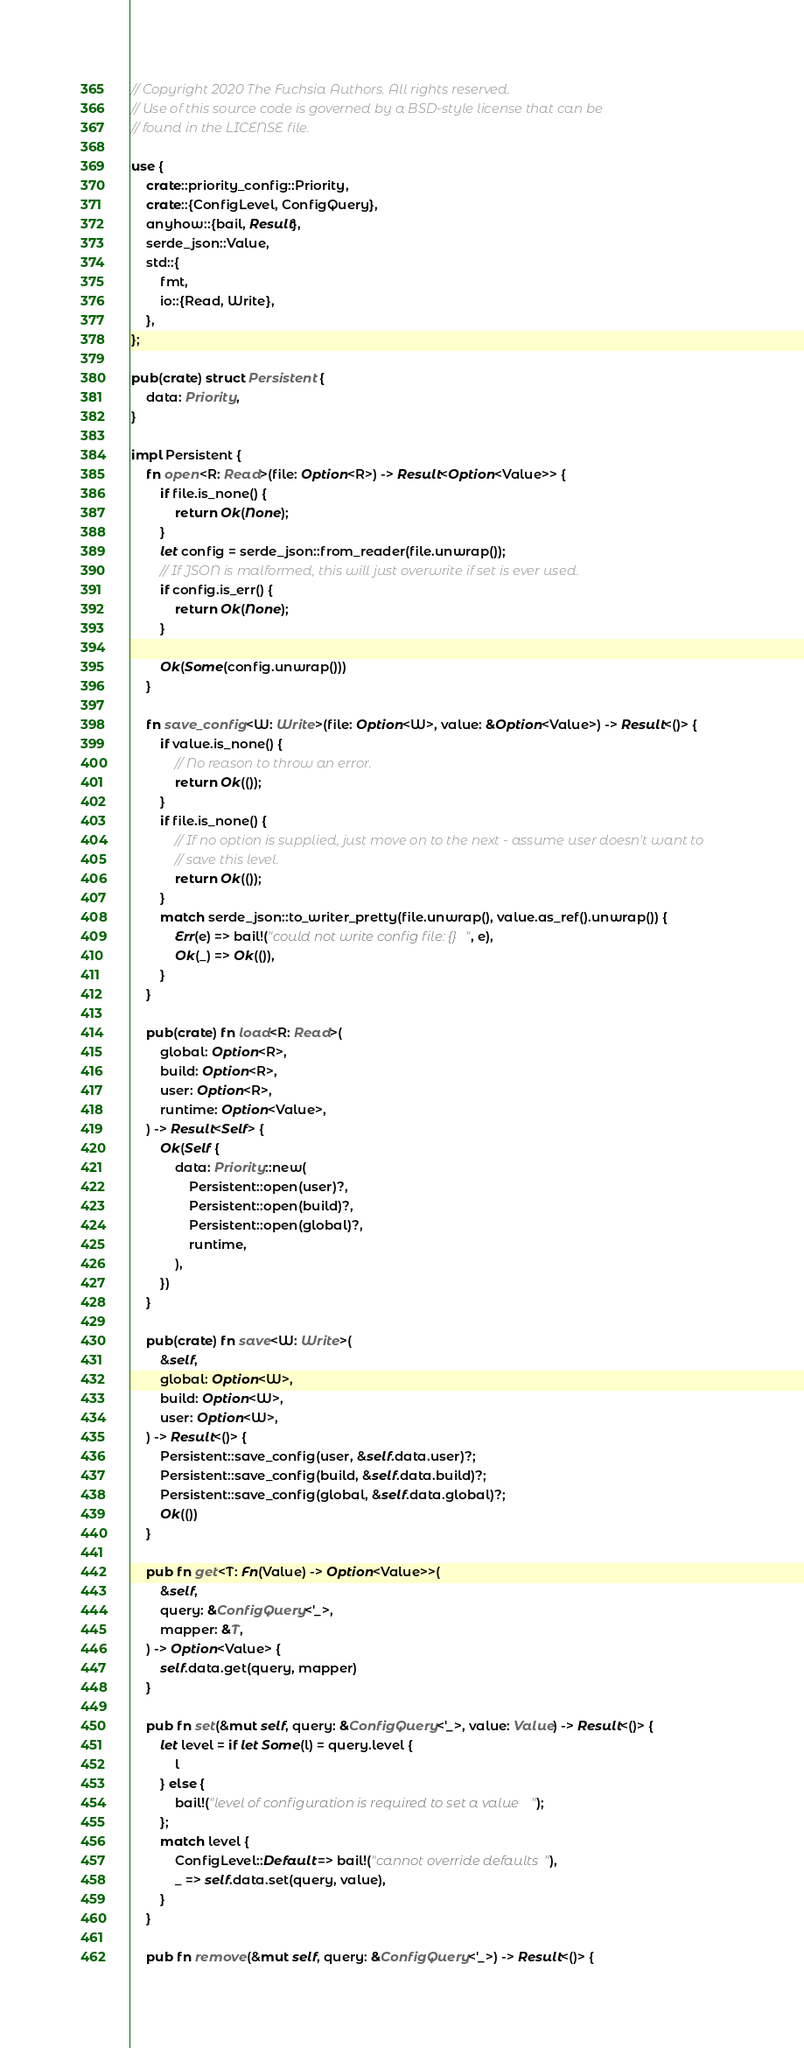Convert code to text. <code><loc_0><loc_0><loc_500><loc_500><_Rust_>// Copyright 2020 The Fuchsia Authors. All rights reserved.
// Use of this source code is governed by a BSD-style license that can be
// found in the LICENSE file.

use {
    crate::priority_config::Priority,
    crate::{ConfigLevel, ConfigQuery},
    anyhow::{bail, Result},
    serde_json::Value,
    std::{
        fmt,
        io::{Read, Write},
    },
};

pub(crate) struct Persistent {
    data: Priority,
}

impl Persistent {
    fn open<R: Read>(file: Option<R>) -> Result<Option<Value>> {
        if file.is_none() {
            return Ok(None);
        }
        let config = serde_json::from_reader(file.unwrap());
        // If JSON is malformed, this will just overwrite if set is ever used.
        if config.is_err() {
            return Ok(None);
        }

        Ok(Some(config.unwrap()))
    }

    fn save_config<W: Write>(file: Option<W>, value: &Option<Value>) -> Result<()> {
        if value.is_none() {
            // No reason to throw an error.
            return Ok(());
        }
        if file.is_none() {
            // If no option is supplied, just move on to the next - assume user doesn't want to
            // save this level.
            return Ok(());
        }
        match serde_json::to_writer_pretty(file.unwrap(), value.as_ref().unwrap()) {
            Err(e) => bail!("could not write config file: {}", e),
            Ok(_) => Ok(()),
        }
    }

    pub(crate) fn load<R: Read>(
        global: Option<R>,
        build: Option<R>,
        user: Option<R>,
        runtime: Option<Value>,
    ) -> Result<Self> {
        Ok(Self {
            data: Priority::new(
                Persistent::open(user)?,
                Persistent::open(build)?,
                Persistent::open(global)?,
                runtime,
            ),
        })
    }

    pub(crate) fn save<W: Write>(
        &self,
        global: Option<W>,
        build: Option<W>,
        user: Option<W>,
    ) -> Result<()> {
        Persistent::save_config(user, &self.data.user)?;
        Persistent::save_config(build, &self.data.build)?;
        Persistent::save_config(global, &self.data.global)?;
        Ok(())
    }

    pub fn get<T: Fn(Value) -> Option<Value>>(
        &self,
        query: &ConfigQuery<'_>,
        mapper: &T,
    ) -> Option<Value> {
        self.data.get(query, mapper)
    }

    pub fn set(&mut self, query: &ConfigQuery<'_>, value: Value) -> Result<()> {
        let level = if let Some(l) = query.level {
            l
        } else {
            bail!("level of configuration is required to set a value");
        };
        match level {
            ConfigLevel::Default => bail!("cannot override defaults"),
            _ => self.data.set(query, value),
        }
    }

    pub fn remove(&mut self, query: &ConfigQuery<'_>) -> Result<()> {</code> 